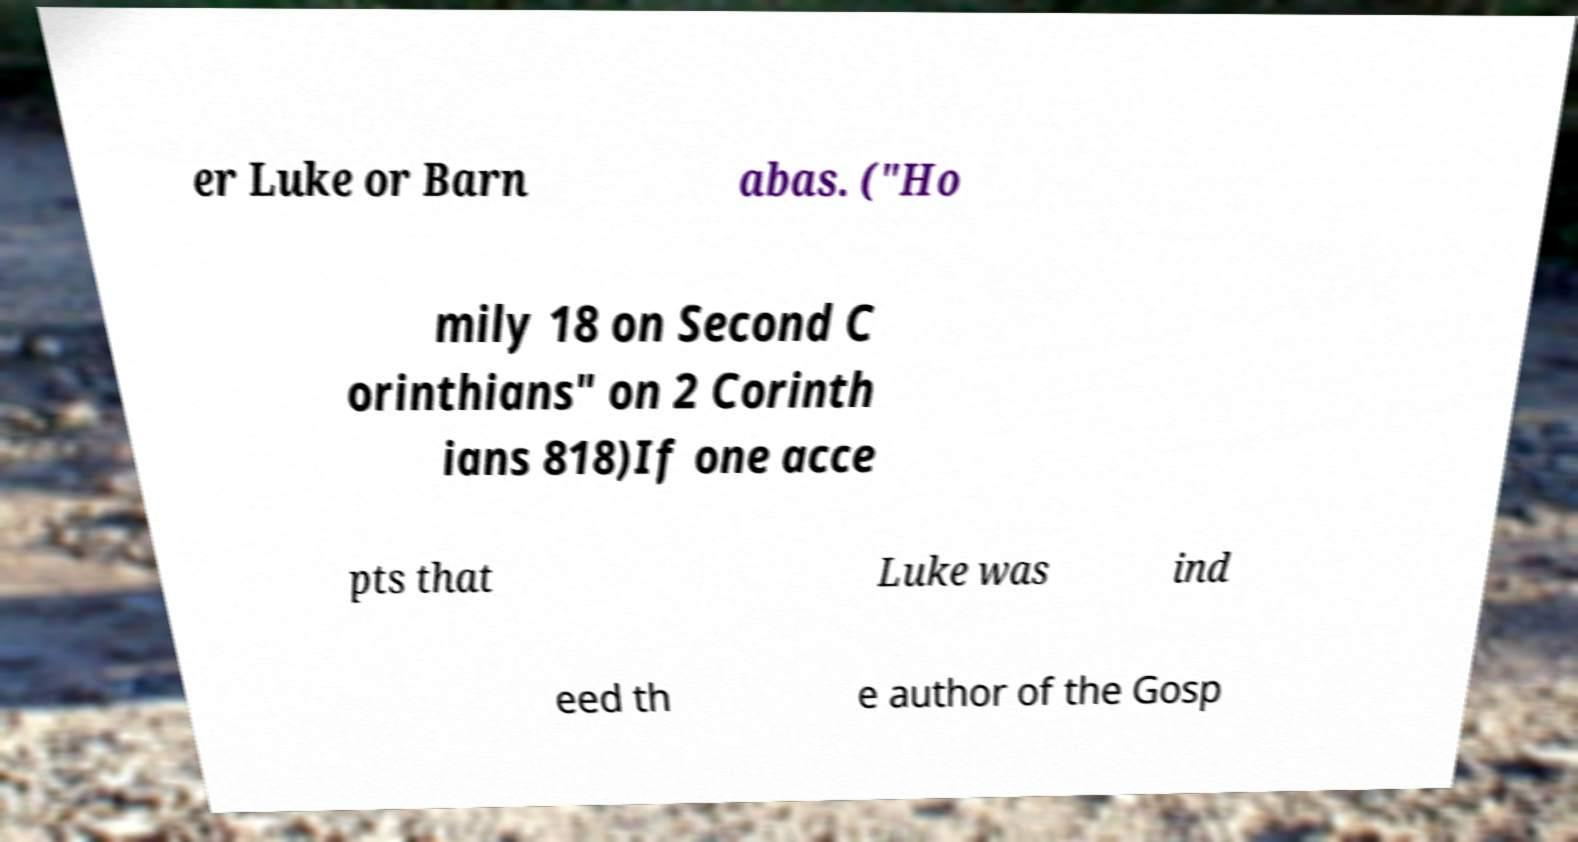Could you assist in decoding the text presented in this image and type it out clearly? er Luke or Barn abas. ("Ho mily 18 on Second C orinthians" on 2 Corinth ians 818)If one acce pts that Luke was ind eed th e author of the Gosp 